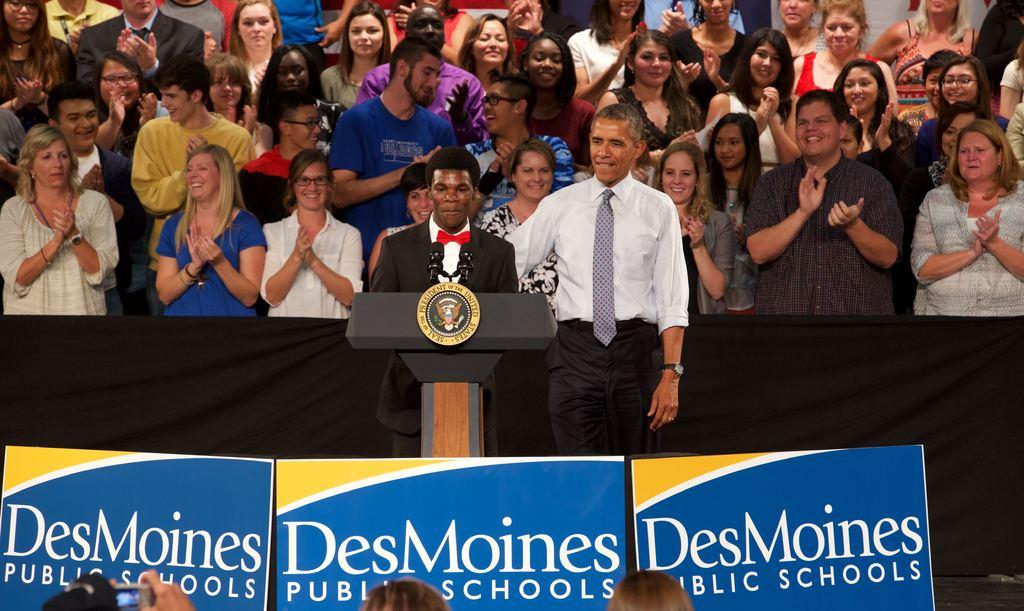Who are the main subjects in the image? There are two people standing in front of a dais. What are the two people holding in the image? The two people are holding placards. Are there any other people visible in the image? Yes, there are a few people standing behind the two people. What are the people standing behind doing? The people standing behind are clapping. Is there a quiet process happening in the image? There is no indication of a quiet process in the image; the people standing behind are clapping, which suggests a more lively atmosphere. 